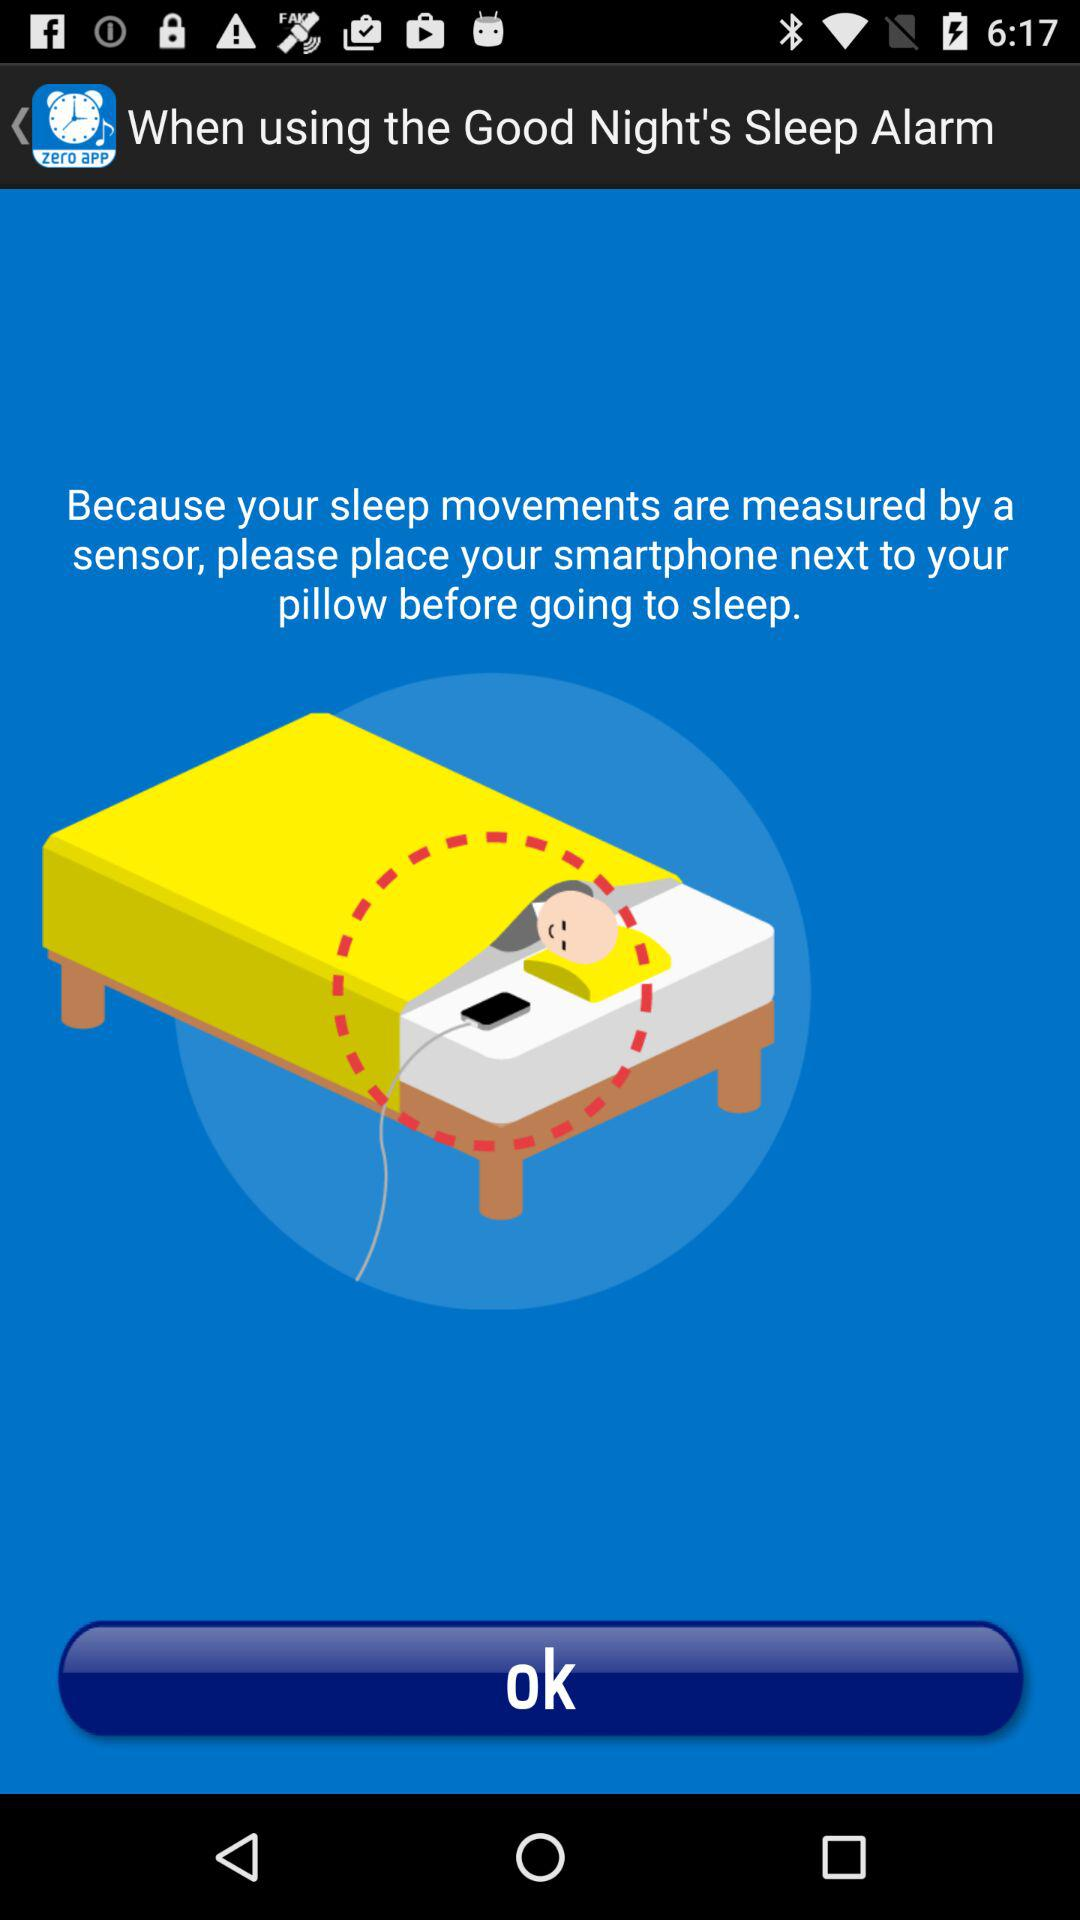What is the name of the application? The name of the application is "zero app". 